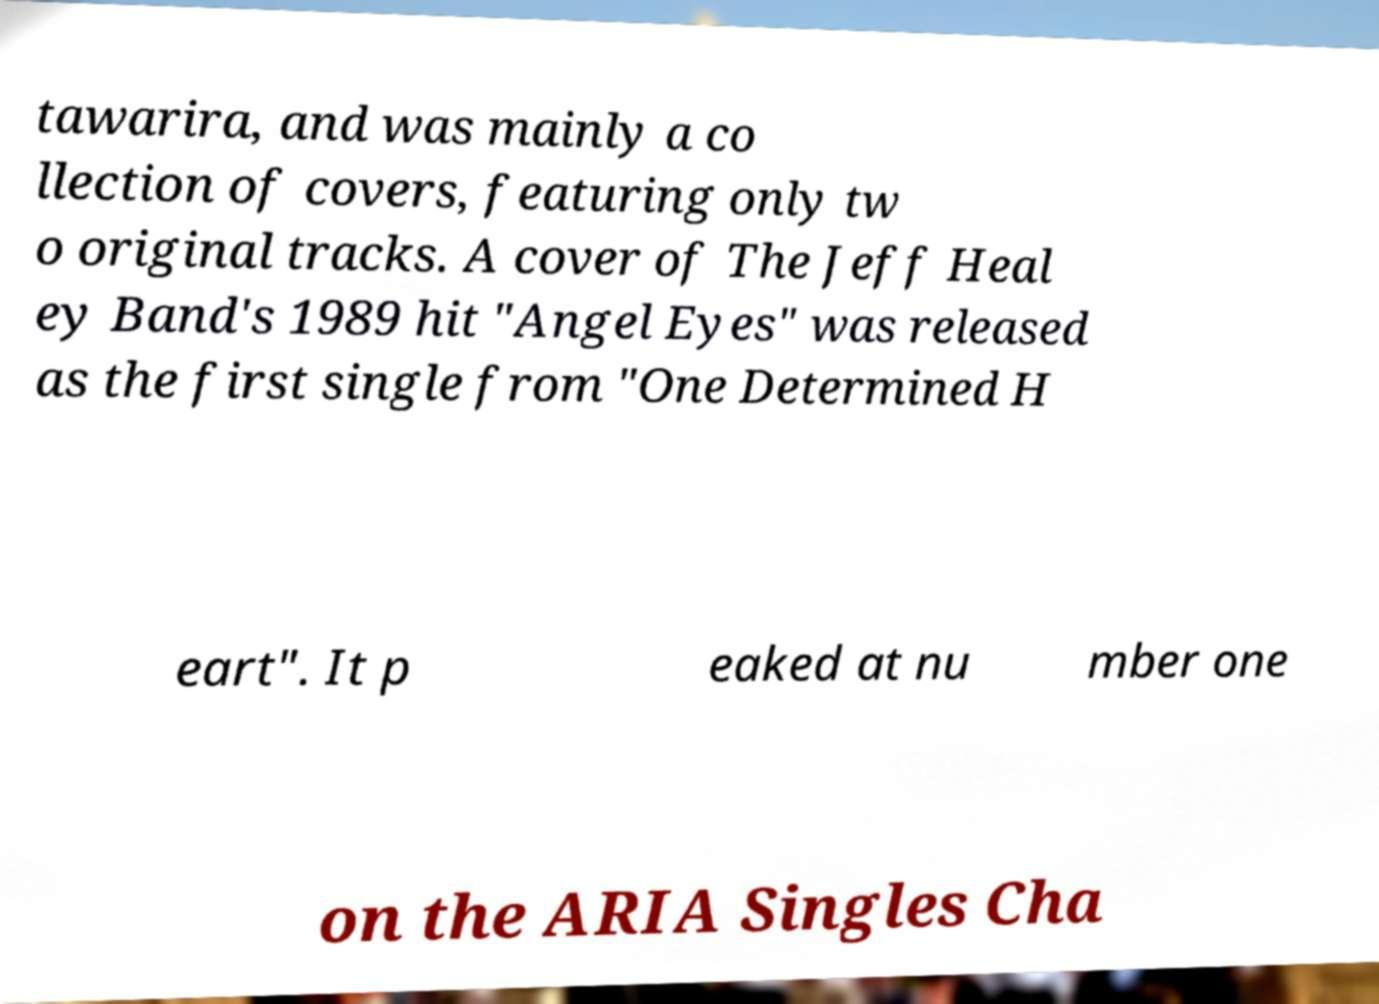Please read and relay the text visible in this image. What does it say? tawarira, and was mainly a co llection of covers, featuring only tw o original tracks. A cover of The Jeff Heal ey Band's 1989 hit "Angel Eyes" was released as the first single from "One Determined H eart". It p eaked at nu mber one on the ARIA Singles Cha 